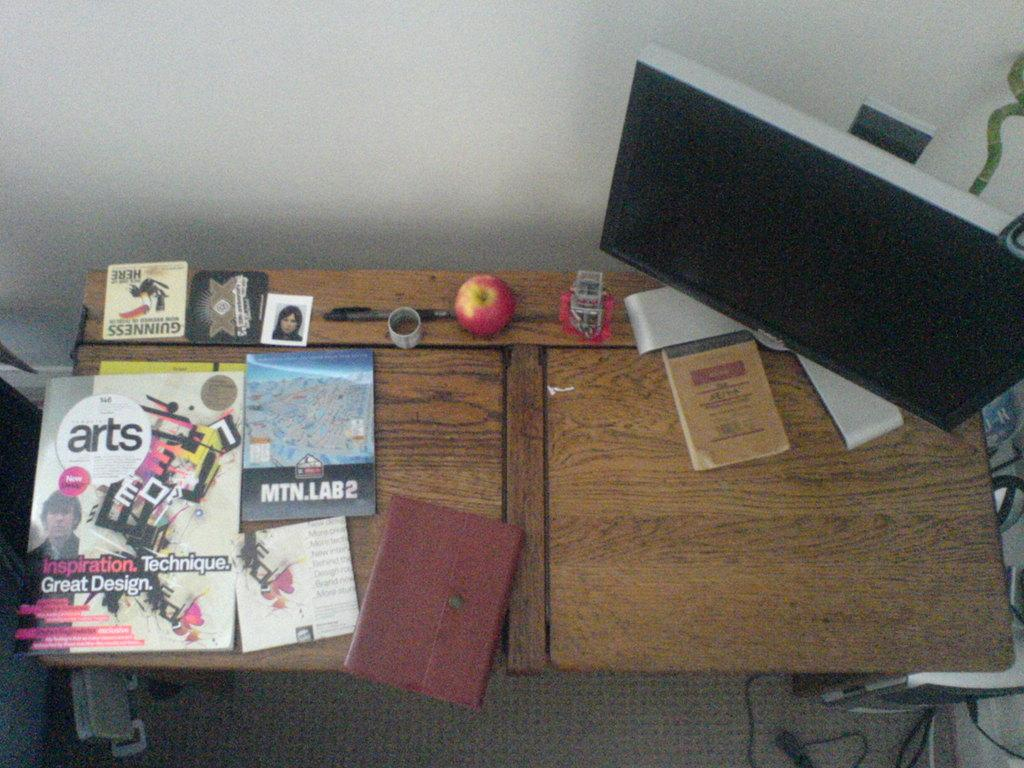What type of table is in the image? There is a wooden table in the image. What items can be seen on the table? There are books, a pad, pens, a photo, fruit, a system (likely a computer or laptop), a dairy (likely a notebook or diary), and other unspecified objects on the table. Can you describe the photo on the table? Unfortunately, the facts provided do not give any details about the photo. What might be used for writing on the pad? The pens on the table might be used for writing on the pad. What is the title of the furniture piece in the image? The image does not contain any furniture other than the wooden table, and there is no title associated with it. Can you touch the touch in the image? There is no "touch" present in the image, so it cannot be touched. 